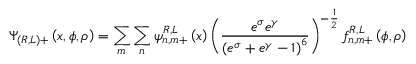Convert formula to latex. <formula><loc_0><loc_0><loc_500><loc_500>\Psi _ { ( R , L ) + } \left ( x , \phi , \rho \right ) = \sum _ { m } \sum _ { n } \psi _ { n , m + } ^ { R , L } \left ( x \right ) \left ( \frac { e ^ { \sigma } e ^ { \gamma } } { \left ( e ^ { \sigma } + e ^ { \gamma } - 1 \right ) ^ { 6 } } \right ) ^ { - \frac { 1 } { 2 } } f _ { n , m + } ^ { R , L } \left ( \phi , \rho \right )</formula> 